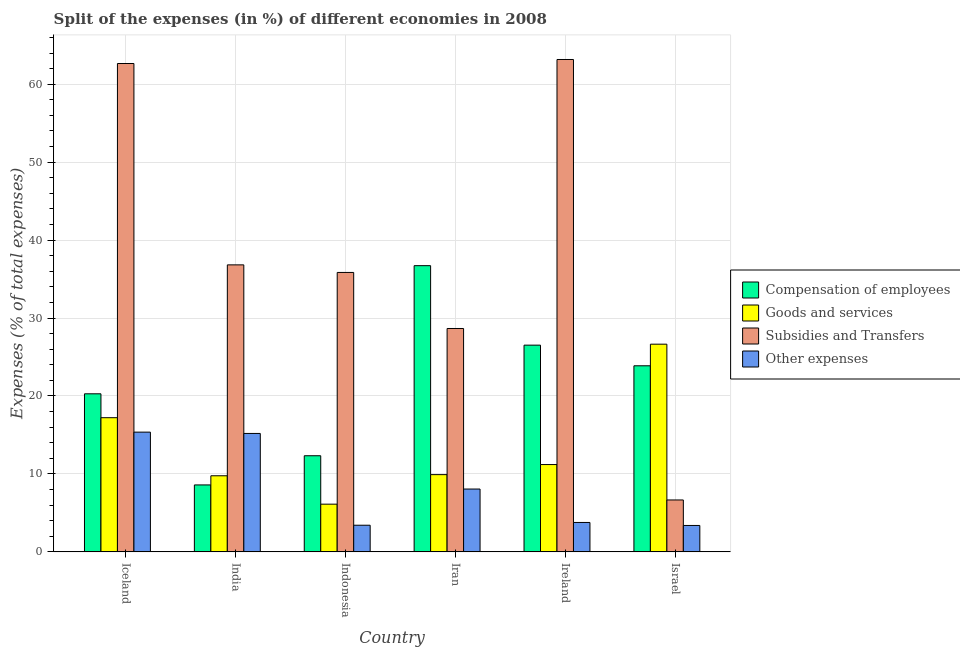How many different coloured bars are there?
Your answer should be very brief. 4. How many groups of bars are there?
Ensure brevity in your answer.  6. Are the number of bars per tick equal to the number of legend labels?
Keep it short and to the point. Yes. Are the number of bars on each tick of the X-axis equal?
Keep it short and to the point. Yes. How many bars are there on the 1st tick from the left?
Provide a short and direct response. 4. How many bars are there on the 4th tick from the right?
Ensure brevity in your answer.  4. What is the label of the 5th group of bars from the left?
Make the answer very short. Ireland. What is the percentage of amount spent on subsidies in Indonesia?
Your answer should be very brief. 35.85. Across all countries, what is the maximum percentage of amount spent on compensation of employees?
Your response must be concise. 36.72. Across all countries, what is the minimum percentage of amount spent on goods and services?
Make the answer very short. 6.12. In which country was the percentage of amount spent on subsidies maximum?
Your response must be concise. Ireland. What is the total percentage of amount spent on subsidies in the graph?
Provide a short and direct response. 233.81. What is the difference between the percentage of amount spent on subsidies in Iceland and that in Ireland?
Your response must be concise. -0.52. What is the difference between the percentage of amount spent on compensation of employees in Iceland and the percentage of amount spent on goods and services in Ireland?
Your answer should be very brief. 9.08. What is the average percentage of amount spent on other expenses per country?
Your answer should be very brief. 8.2. What is the difference between the percentage of amount spent on compensation of employees and percentage of amount spent on other expenses in Ireland?
Make the answer very short. 22.75. What is the ratio of the percentage of amount spent on subsidies in Iceland to that in Ireland?
Your response must be concise. 0.99. Is the percentage of amount spent on goods and services in Indonesia less than that in Israel?
Provide a short and direct response. Yes. What is the difference between the highest and the second highest percentage of amount spent on goods and services?
Offer a very short reply. 9.43. What is the difference between the highest and the lowest percentage of amount spent on subsidies?
Give a very brief answer. 56.51. Is the sum of the percentage of amount spent on subsidies in Iceland and Indonesia greater than the maximum percentage of amount spent on other expenses across all countries?
Give a very brief answer. Yes. What does the 2nd bar from the left in Iran represents?
Your response must be concise. Goods and services. What does the 1st bar from the right in Israel represents?
Your answer should be very brief. Other expenses. How many bars are there?
Provide a short and direct response. 24. How are the legend labels stacked?
Your answer should be compact. Vertical. What is the title of the graph?
Provide a succinct answer. Split of the expenses (in %) of different economies in 2008. What is the label or title of the X-axis?
Ensure brevity in your answer.  Country. What is the label or title of the Y-axis?
Ensure brevity in your answer.  Expenses (% of total expenses). What is the Expenses (% of total expenses) of Compensation of employees in Iceland?
Offer a terse response. 20.28. What is the Expenses (% of total expenses) in Goods and services in Iceland?
Keep it short and to the point. 17.22. What is the Expenses (% of total expenses) in Subsidies and Transfers in Iceland?
Your answer should be very brief. 62.65. What is the Expenses (% of total expenses) of Other expenses in Iceland?
Your answer should be compact. 15.36. What is the Expenses (% of total expenses) of Compensation of employees in India?
Provide a succinct answer. 8.59. What is the Expenses (% of total expenses) of Goods and services in India?
Provide a succinct answer. 9.76. What is the Expenses (% of total expenses) in Subsidies and Transfers in India?
Offer a terse response. 36.82. What is the Expenses (% of total expenses) of Other expenses in India?
Provide a succinct answer. 15.19. What is the Expenses (% of total expenses) of Compensation of employees in Indonesia?
Offer a terse response. 12.33. What is the Expenses (% of total expenses) in Goods and services in Indonesia?
Your answer should be very brief. 6.12. What is the Expenses (% of total expenses) in Subsidies and Transfers in Indonesia?
Make the answer very short. 35.85. What is the Expenses (% of total expenses) in Other expenses in Indonesia?
Provide a short and direct response. 3.42. What is the Expenses (% of total expenses) in Compensation of employees in Iran?
Your answer should be compact. 36.72. What is the Expenses (% of total expenses) in Goods and services in Iran?
Make the answer very short. 9.91. What is the Expenses (% of total expenses) in Subsidies and Transfers in Iran?
Your answer should be compact. 28.66. What is the Expenses (% of total expenses) of Other expenses in Iran?
Your answer should be compact. 8.06. What is the Expenses (% of total expenses) of Compensation of employees in Ireland?
Offer a terse response. 26.52. What is the Expenses (% of total expenses) in Goods and services in Ireland?
Keep it short and to the point. 11.2. What is the Expenses (% of total expenses) of Subsidies and Transfers in Ireland?
Keep it short and to the point. 63.17. What is the Expenses (% of total expenses) in Other expenses in Ireland?
Your answer should be compact. 3.77. What is the Expenses (% of total expenses) of Compensation of employees in Israel?
Offer a very short reply. 23.87. What is the Expenses (% of total expenses) of Goods and services in Israel?
Offer a terse response. 26.65. What is the Expenses (% of total expenses) of Subsidies and Transfers in Israel?
Offer a very short reply. 6.66. What is the Expenses (% of total expenses) in Other expenses in Israel?
Your response must be concise. 3.39. Across all countries, what is the maximum Expenses (% of total expenses) in Compensation of employees?
Provide a short and direct response. 36.72. Across all countries, what is the maximum Expenses (% of total expenses) in Goods and services?
Your answer should be compact. 26.65. Across all countries, what is the maximum Expenses (% of total expenses) in Subsidies and Transfers?
Offer a terse response. 63.17. Across all countries, what is the maximum Expenses (% of total expenses) in Other expenses?
Make the answer very short. 15.36. Across all countries, what is the minimum Expenses (% of total expenses) in Compensation of employees?
Your response must be concise. 8.59. Across all countries, what is the minimum Expenses (% of total expenses) of Goods and services?
Your response must be concise. 6.12. Across all countries, what is the minimum Expenses (% of total expenses) of Subsidies and Transfers?
Your answer should be compact. 6.66. Across all countries, what is the minimum Expenses (% of total expenses) in Other expenses?
Keep it short and to the point. 3.39. What is the total Expenses (% of total expenses) of Compensation of employees in the graph?
Make the answer very short. 128.32. What is the total Expenses (% of total expenses) of Goods and services in the graph?
Offer a very short reply. 80.86. What is the total Expenses (% of total expenses) of Subsidies and Transfers in the graph?
Provide a short and direct response. 233.81. What is the total Expenses (% of total expenses) of Other expenses in the graph?
Your answer should be compact. 49.2. What is the difference between the Expenses (% of total expenses) of Compensation of employees in Iceland and that in India?
Ensure brevity in your answer.  11.69. What is the difference between the Expenses (% of total expenses) of Goods and services in Iceland and that in India?
Your answer should be compact. 7.45. What is the difference between the Expenses (% of total expenses) in Subsidies and Transfers in Iceland and that in India?
Offer a very short reply. 25.83. What is the difference between the Expenses (% of total expenses) of Other expenses in Iceland and that in India?
Give a very brief answer. 0.17. What is the difference between the Expenses (% of total expenses) of Compensation of employees in Iceland and that in Indonesia?
Offer a very short reply. 7.95. What is the difference between the Expenses (% of total expenses) of Goods and services in Iceland and that in Indonesia?
Provide a succinct answer. 11.09. What is the difference between the Expenses (% of total expenses) of Subsidies and Transfers in Iceland and that in Indonesia?
Provide a succinct answer. 26.81. What is the difference between the Expenses (% of total expenses) in Other expenses in Iceland and that in Indonesia?
Your answer should be compact. 11.94. What is the difference between the Expenses (% of total expenses) in Compensation of employees in Iceland and that in Iran?
Provide a succinct answer. -16.44. What is the difference between the Expenses (% of total expenses) of Goods and services in Iceland and that in Iran?
Ensure brevity in your answer.  7.31. What is the difference between the Expenses (% of total expenses) of Subsidies and Transfers in Iceland and that in Iran?
Your response must be concise. 34. What is the difference between the Expenses (% of total expenses) of Other expenses in Iceland and that in Iran?
Your answer should be very brief. 7.3. What is the difference between the Expenses (% of total expenses) of Compensation of employees in Iceland and that in Ireland?
Your answer should be compact. -6.24. What is the difference between the Expenses (% of total expenses) in Goods and services in Iceland and that in Ireland?
Ensure brevity in your answer.  6.01. What is the difference between the Expenses (% of total expenses) of Subsidies and Transfers in Iceland and that in Ireland?
Provide a short and direct response. -0.52. What is the difference between the Expenses (% of total expenses) of Other expenses in Iceland and that in Ireland?
Provide a short and direct response. 11.59. What is the difference between the Expenses (% of total expenses) in Compensation of employees in Iceland and that in Israel?
Your response must be concise. -3.6. What is the difference between the Expenses (% of total expenses) of Goods and services in Iceland and that in Israel?
Keep it short and to the point. -9.43. What is the difference between the Expenses (% of total expenses) of Subsidies and Transfers in Iceland and that in Israel?
Keep it short and to the point. 56. What is the difference between the Expenses (% of total expenses) in Other expenses in Iceland and that in Israel?
Your response must be concise. 11.97. What is the difference between the Expenses (% of total expenses) in Compensation of employees in India and that in Indonesia?
Offer a terse response. -3.74. What is the difference between the Expenses (% of total expenses) in Goods and services in India and that in Indonesia?
Your response must be concise. 3.64. What is the difference between the Expenses (% of total expenses) in Subsidies and Transfers in India and that in Indonesia?
Give a very brief answer. 0.97. What is the difference between the Expenses (% of total expenses) in Other expenses in India and that in Indonesia?
Your answer should be compact. 11.77. What is the difference between the Expenses (% of total expenses) in Compensation of employees in India and that in Iran?
Provide a succinct answer. -28.13. What is the difference between the Expenses (% of total expenses) in Goods and services in India and that in Iran?
Offer a terse response. -0.15. What is the difference between the Expenses (% of total expenses) of Subsidies and Transfers in India and that in Iran?
Provide a short and direct response. 8.16. What is the difference between the Expenses (% of total expenses) in Other expenses in India and that in Iran?
Make the answer very short. 7.13. What is the difference between the Expenses (% of total expenses) of Compensation of employees in India and that in Ireland?
Your response must be concise. -17.93. What is the difference between the Expenses (% of total expenses) in Goods and services in India and that in Ireland?
Keep it short and to the point. -1.44. What is the difference between the Expenses (% of total expenses) in Subsidies and Transfers in India and that in Ireland?
Your answer should be very brief. -26.35. What is the difference between the Expenses (% of total expenses) in Other expenses in India and that in Ireland?
Your answer should be compact. 11.42. What is the difference between the Expenses (% of total expenses) in Compensation of employees in India and that in Israel?
Ensure brevity in your answer.  -15.29. What is the difference between the Expenses (% of total expenses) in Goods and services in India and that in Israel?
Make the answer very short. -16.88. What is the difference between the Expenses (% of total expenses) in Subsidies and Transfers in India and that in Israel?
Offer a very short reply. 30.16. What is the difference between the Expenses (% of total expenses) of Other expenses in India and that in Israel?
Provide a succinct answer. 11.8. What is the difference between the Expenses (% of total expenses) of Compensation of employees in Indonesia and that in Iran?
Your answer should be very brief. -24.39. What is the difference between the Expenses (% of total expenses) in Goods and services in Indonesia and that in Iran?
Provide a short and direct response. -3.79. What is the difference between the Expenses (% of total expenses) of Subsidies and Transfers in Indonesia and that in Iran?
Your answer should be very brief. 7.19. What is the difference between the Expenses (% of total expenses) in Other expenses in Indonesia and that in Iran?
Give a very brief answer. -4.64. What is the difference between the Expenses (% of total expenses) in Compensation of employees in Indonesia and that in Ireland?
Provide a short and direct response. -14.19. What is the difference between the Expenses (% of total expenses) in Goods and services in Indonesia and that in Ireland?
Your answer should be very brief. -5.08. What is the difference between the Expenses (% of total expenses) in Subsidies and Transfers in Indonesia and that in Ireland?
Keep it short and to the point. -27.32. What is the difference between the Expenses (% of total expenses) of Other expenses in Indonesia and that in Ireland?
Provide a short and direct response. -0.35. What is the difference between the Expenses (% of total expenses) in Compensation of employees in Indonesia and that in Israel?
Keep it short and to the point. -11.54. What is the difference between the Expenses (% of total expenses) in Goods and services in Indonesia and that in Israel?
Ensure brevity in your answer.  -20.52. What is the difference between the Expenses (% of total expenses) of Subsidies and Transfers in Indonesia and that in Israel?
Provide a short and direct response. 29.19. What is the difference between the Expenses (% of total expenses) in Other expenses in Indonesia and that in Israel?
Give a very brief answer. 0.03. What is the difference between the Expenses (% of total expenses) in Compensation of employees in Iran and that in Ireland?
Ensure brevity in your answer.  10.2. What is the difference between the Expenses (% of total expenses) in Goods and services in Iran and that in Ireland?
Provide a short and direct response. -1.29. What is the difference between the Expenses (% of total expenses) in Subsidies and Transfers in Iran and that in Ireland?
Your answer should be very brief. -34.51. What is the difference between the Expenses (% of total expenses) in Other expenses in Iran and that in Ireland?
Provide a succinct answer. 4.29. What is the difference between the Expenses (% of total expenses) of Compensation of employees in Iran and that in Israel?
Your response must be concise. 12.85. What is the difference between the Expenses (% of total expenses) of Goods and services in Iran and that in Israel?
Provide a short and direct response. -16.74. What is the difference between the Expenses (% of total expenses) in Subsidies and Transfers in Iran and that in Israel?
Keep it short and to the point. 22. What is the difference between the Expenses (% of total expenses) of Other expenses in Iran and that in Israel?
Keep it short and to the point. 4.67. What is the difference between the Expenses (% of total expenses) of Compensation of employees in Ireland and that in Israel?
Your answer should be very brief. 2.65. What is the difference between the Expenses (% of total expenses) of Goods and services in Ireland and that in Israel?
Provide a succinct answer. -15.44. What is the difference between the Expenses (% of total expenses) in Subsidies and Transfers in Ireland and that in Israel?
Your response must be concise. 56.51. What is the difference between the Expenses (% of total expenses) of Other expenses in Ireland and that in Israel?
Your response must be concise. 0.39. What is the difference between the Expenses (% of total expenses) of Compensation of employees in Iceland and the Expenses (% of total expenses) of Goods and services in India?
Keep it short and to the point. 10.52. What is the difference between the Expenses (% of total expenses) of Compensation of employees in Iceland and the Expenses (% of total expenses) of Subsidies and Transfers in India?
Give a very brief answer. -16.54. What is the difference between the Expenses (% of total expenses) of Compensation of employees in Iceland and the Expenses (% of total expenses) of Other expenses in India?
Offer a terse response. 5.08. What is the difference between the Expenses (% of total expenses) of Goods and services in Iceland and the Expenses (% of total expenses) of Subsidies and Transfers in India?
Offer a terse response. -19.61. What is the difference between the Expenses (% of total expenses) of Goods and services in Iceland and the Expenses (% of total expenses) of Other expenses in India?
Provide a short and direct response. 2.02. What is the difference between the Expenses (% of total expenses) of Subsidies and Transfers in Iceland and the Expenses (% of total expenses) of Other expenses in India?
Your response must be concise. 47.46. What is the difference between the Expenses (% of total expenses) of Compensation of employees in Iceland and the Expenses (% of total expenses) of Goods and services in Indonesia?
Your answer should be very brief. 14.16. What is the difference between the Expenses (% of total expenses) in Compensation of employees in Iceland and the Expenses (% of total expenses) in Subsidies and Transfers in Indonesia?
Give a very brief answer. -15.57. What is the difference between the Expenses (% of total expenses) in Compensation of employees in Iceland and the Expenses (% of total expenses) in Other expenses in Indonesia?
Make the answer very short. 16.86. What is the difference between the Expenses (% of total expenses) in Goods and services in Iceland and the Expenses (% of total expenses) in Subsidies and Transfers in Indonesia?
Your answer should be compact. -18.63. What is the difference between the Expenses (% of total expenses) in Goods and services in Iceland and the Expenses (% of total expenses) in Other expenses in Indonesia?
Your answer should be very brief. 13.8. What is the difference between the Expenses (% of total expenses) in Subsidies and Transfers in Iceland and the Expenses (% of total expenses) in Other expenses in Indonesia?
Give a very brief answer. 59.24. What is the difference between the Expenses (% of total expenses) of Compensation of employees in Iceland and the Expenses (% of total expenses) of Goods and services in Iran?
Ensure brevity in your answer.  10.37. What is the difference between the Expenses (% of total expenses) in Compensation of employees in Iceland and the Expenses (% of total expenses) in Subsidies and Transfers in Iran?
Offer a very short reply. -8.38. What is the difference between the Expenses (% of total expenses) of Compensation of employees in Iceland and the Expenses (% of total expenses) of Other expenses in Iran?
Provide a succinct answer. 12.22. What is the difference between the Expenses (% of total expenses) in Goods and services in Iceland and the Expenses (% of total expenses) in Subsidies and Transfers in Iran?
Your response must be concise. -11.44. What is the difference between the Expenses (% of total expenses) in Goods and services in Iceland and the Expenses (% of total expenses) in Other expenses in Iran?
Keep it short and to the point. 9.15. What is the difference between the Expenses (% of total expenses) in Subsidies and Transfers in Iceland and the Expenses (% of total expenses) in Other expenses in Iran?
Provide a short and direct response. 54.59. What is the difference between the Expenses (% of total expenses) in Compensation of employees in Iceland and the Expenses (% of total expenses) in Goods and services in Ireland?
Give a very brief answer. 9.08. What is the difference between the Expenses (% of total expenses) of Compensation of employees in Iceland and the Expenses (% of total expenses) of Subsidies and Transfers in Ireland?
Provide a succinct answer. -42.89. What is the difference between the Expenses (% of total expenses) of Compensation of employees in Iceland and the Expenses (% of total expenses) of Other expenses in Ireland?
Make the answer very short. 16.5. What is the difference between the Expenses (% of total expenses) in Goods and services in Iceland and the Expenses (% of total expenses) in Subsidies and Transfers in Ireland?
Your response must be concise. -45.95. What is the difference between the Expenses (% of total expenses) in Goods and services in Iceland and the Expenses (% of total expenses) in Other expenses in Ireland?
Your answer should be very brief. 13.44. What is the difference between the Expenses (% of total expenses) in Subsidies and Transfers in Iceland and the Expenses (% of total expenses) in Other expenses in Ireland?
Offer a very short reply. 58.88. What is the difference between the Expenses (% of total expenses) of Compensation of employees in Iceland and the Expenses (% of total expenses) of Goods and services in Israel?
Provide a short and direct response. -6.37. What is the difference between the Expenses (% of total expenses) in Compensation of employees in Iceland and the Expenses (% of total expenses) in Subsidies and Transfers in Israel?
Make the answer very short. 13.62. What is the difference between the Expenses (% of total expenses) of Compensation of employees in Iceland and the Expenses (% of total expenses) of Other expenses in Israel?
Ensure brevity in your answer.  16.89. What is the difference between the Expenses (% of total expenses) of Goods and services in Iceland and the Expenses (% of total expenses) of Subsidies and Transfers in Israel?
Offer a terse response. 10.56. What is the difference between the Expenses (% of total expenses) in Goods and services in Iceland and the Expenses (% of total expenses) in Other expenses in Israel?
Ensure brevity in your answer.  13.83. What is the difference between the Expenses (% of total expenses) of Subsidies and Transfers in Iceland and the Expenses (% of total expenses) of Other expenses in Israel?
Ensure brevity in your answer.  59.27. What is the difference between the Expenses (% of total expenses) in Compensation of employees in India and the Expenses (% of total expenses) in Goods and services in Indonesia?
Make the answer very short. 2.47. What is the difference between the Expenses (% of total expenses) in Compensation of employees in India and the Expenses (% of total expenses) in Subsidies and Transfers in Indonesia?
Offer a very short reply. -27.26. What is the difference between the Expenses (% of total expenses) in Compensation of employees in India and the Expenses (% of total expenses) in Other expenses in Indonesia?
Provide a succinct answer. 5.17. What is the difference between the Expenses (% of total expenses) of Goods and services in India and the Expenses (% of total expenses) of Subsidies and Transfers in Indonesia?
Make the answer very short. -26.09. What is the difference between the Expenses (% of total expenses) of Goods and services in India and the Expenses (% of total expenses) of Other expenses in Indonesia?
Your answer should be very brief. 6.34. What is the difference between the Expenses (% of total expenses) in Subsidies and Transfers in India and the Expenses (% of total expenses) in Other expenses in Indonesia?
Your answer should be very brief. 33.4. What is the difference between the Expenses (% of total expenses) of Compensation of employees in India and the Expenses (% of total expenses) of Goods and services in Iran?
Your response must be concise. -1.32. What is the difference between the Expenses (% of total expenses) of Compensation of employees in India and the Expenses (% of total expenses) of Subsidies and Transfers in Iran?
Keep it short and to the point. -20.07. What is the difference between the Expenses (% of total expenses) of Compensation of employees in India and the Expenses (% of total expenses) of Other expenses in Iran?
Your response must be concise. 0.53. What is the difference between the Expenses (% of total expenses) in Goods and services in India and the Expenses (% of total expenses) in Subsidies and Transfers in Iran?
Provide a short and direct response. -18.89. What is the difference between the Expenses (% of total expenses) of Goods and services in India and the Expenses (% of total expenses) of Other expenses in Iran?
Provide a succinct answer. 1.7. What is the difference between the Expenses (% of total expenses) in Subsidies and Transfers in India and the Expenses (% of total expenses) in Other expenses in Iran?
Keep it short and to the point. 28.76. What is the difference between the Expenses (% of total expenses) in Compensation of employees in India and the Expenses (% of total expenses) in Goods and services in Ireland?
Your answer should be compact. -2.61. What is the difference between the Expenses (% of total expenses) in Compensation of employees in India and the Expenses (% of total expenses) in Subsidies and Transfers in Ireland?
Your answer should be very brief. -54.58. What is the difference between the Expenses (% of total expenses) in Compensation of employees in India and the Expenses (% of total expenses) in Other expenses in Ireland?
Ensure brevity in your answer.  4.81. What is the difference between the Expenses (% of total expenses) in Goods and services in India and the Expenses (% of total expenses) in Subsidies and Transfers in Ireland?
Your answer should be very brief. -53.41. What is the difference between the Expenses (% of total expenses) of Goods and services in India and the Expenses (% of total expenses) of Other expenses in Ireland?
Offer a very short reply. 5.99. What is the difference between the Expenses (% of total expenses) in Subsidies and Transfers in India and the Expenses (% of total expenses) in Other expenses in Ireland?
Keep it short and to the point. 33.05. What is the difference between the Expenses (% of total expenses) of Compensation of employees in India and the Expenses (% of total expenses) of Goods and services in Israel?
Your response must be concise. -18.06. What is the difference between the Expenses (% of total expenses) in Compensation of employees in India and the Expenses (% of total expenses) in Subsidies and Transfers in Israel?
Provide a short and direct response. 1.93. What is the difference between the Expenses (% of total expenses) in Compensation of employees in India and the Expenses (% of total expenses) in Other expenses in Israel?
Give a very brief answer. 5.2. What is the difference between the Expenses (% of total expenses) of Goods and services in India and the Expenses (% of total expenses) of Subsidies and Transfers in Israel?
Offer a terse response. 3.1. What is the difference between the Expenses (% of total expenses) in Goods and services in India and the Expenses (% of total expenses) in Other expenses in Israel?
Offer a terse response. 6.37. What is the difference between the Expenses (% of total expenses) of Subsidies and Transfers in India and the Expenses (% of total expenses) of Other expenses in Israel?
Provide a succinct answer. 33.43. What is the difference between the Expenses (% of total expenses) of Compensation of employees in Indonesia and the Expenses (% of total expenses) of Goods and services in Iran?
Keep it short and to the point. 2.42. What is the difference between the Expenses (% of total expenses) in Compensation of employees in Indonesia and the Expenses (% of total expenses) in Subsidies and Transfers in Iran?
Your response must be concise. -16.33. What is the difference between the Expenses (% of total expenses) of Compensation of employees in Indonesia and the Expenses (% of total expenses) of Other expenses in Iran?
Make the answer very short. 4.27. What is the difference between the Expenses (% of total expenses) of Goods and services in Indonesia and the Expenses (% of total expenses) of Subsidies and Transfers in Iran?
Your response must be concise. -22.54. What is the difference between the Expenses (% of total expenses) of Goods and services in Indonesia and the Expenses (% of total expenses) of Other expenses in Iran?
Keep it short and to the point. -1.94. What is the difference between the Expenses (% of total expenses) in Subsidies and Transfers in Indonesia and the Expenses (% of total expenses) in Other expenses in Iran?
Make the answer very short. 27.79. What is the difference between the Expenses (% of total expenses) in Compensation of employees in Indonesia and the Expenses (% of total expenses) in Goods and services in Ireland?
Keep it short and to the point. 1.13. What is the difference between the Expenses (% of total expenses) in Compensation of employees in Indonesia and the Expenses (% of total expenses) in Subsidies and Transfers in Ireland?
Give a very brief answer. -50.84. What is the difference between the Expenses (% of total expenses) of Compensation of employees in Indonesia and the Expenses (% of total expenses) of Other expenses in Ireland?
Your answer should be compact. 8.56. What is the difference between the Expenses (% of total expenses) of Goods and services in Indonesia and the Expenses (% of total expenses) of Subsidies and Transfers in Ireland?
Give a very brief answer. -57.05. What is the difference between the Expenses (% of total expenses) of Goods and services in Indonesia and the Expenses (% of total expenses) of Other expenses in Ireland?
Offer a very short reply. 2.35. What is the difference between the Expenses (% of total expenses) of Subsidies and Transfers in Indonesia and the Expenses (% of total expenses) of Other expenses in Ireland?
Offer a terse response. 32.07. What is the difference between the Expenses (% of total expenses) of Compensation of employees in Indonesia and the Expenses (% of total expenses) of Goods and services in Israel?
Offer a very short reply. -14.31. What is the difference between the Expenses (% of total expenses) of Compensation of employees in Indonesia and the Expenses (% of total expenses) of Subsidies and Transfers in Israel?
Ensure brevity in your answer.  5.67. What is the difference between the Expenses (% of total expenses) of Compensation of employees in Indonesia and the Expenses (% of total expenses) of Other expenses in Israel?
Ensure brevity in your answer.  8.94. What is the difference between the Expenses (% of total expenses) of Goods and services in Indonesia and the Expenses (% of total expenses) of Subsidies and Transfers in Israel?
Offer a very short reply. -0.54. What is the difference between the Expenses (% of total expenses) in Goods and services in Indonesia and the Expenses (% of total expenses) in Other expenses in Israel?
Your response must be concise. 2.73. What is the difference between the Expenses (% of total expenses) of Subsidies and Transfers in Indonesia and the Expenses (% of total expenses) of Other expenses in Israel?
Give a very brief answer. 32.46. What is the difference between the Expenses (% of total expenses) in Compensation of employees in Iran and the Expenses (% of total expenses) in Goods and services in Ireland?
Your response must be concise. 25.52. What is the difference between the Expenses (% of total expenses) in Compensation of employees in Iran and the Expenses (% of total expenses) in Subsidies and Transfers in Ireland?
Your answer should be compact. -26.45. What is the difference between the Expenses (% of total expenses) in Compensation of employees in Iran and the Expenses (% of total expenses) in Other expenses in Ireland?
Give a very brief answer. 32.95. What is the difference between the Expenses (% of total expenses) in Goods and services in Iran and the Expenses (% of total expenses) in Subsidies and Transfers in Ireland?
Offer a terse response. -53.26. What is the difference between the Expenses (% of total expenses) of Goods and services in Iran and the Expenses (% of total expenses) of Other expenses in Ireland?
Offer a very short reply. 6.14. What is the difference between the Expenses (% of total expenses) of Subsidies and Transfers in Iran and the Expenses (% of total expenses) of Other expenses in Ireland?
Provide a succinct answer. 24.88. What is the difference between the Expenses (% of total expenses) of Compensation of employees in Iran and the Expenses (% of total expenses) of Goods and services in Israel?
Your answer should be very brief. 10.07. What is the difference between the Expenses (% of total expenses) in Compensation of employees in Iran and the Expenses (% of total expenses) in Subsidies and Transfers in Israel?
Offer a very short reply. 30.06. What is the difference between the Expenses (% of total expenses) in Compensation of employees in Iran and the Expenses (% of total expenses) in Other expenses in Israel?
Offer a terse response. 33.33. What is the difference between the Expenses (% of total expenses) in Goods and services in Iran and the Expenses (% of total expenses) in Subsidies and Transfers in Israel?
Keep it short and to the point. 3.25. What is the difference between the Expenses (% of total expenses) of Goods and services in Iran and the Expenses (% of total expenses) of Other expenses in Israel?
Provide a succinct answer. 6.52. What is the difference between the Expenses (% of total expenses) in Subsidies and Transfers in Iran and the Expenses (% of total expenses) in Other expenses in Israel?
Your answer should be compact. 25.27. What is the difference between the Expenses (% of total expenses) of Compensation of employees in Ireland and the Expenses (% of total expenses) of Goods and services in Israel?
Ensure brevity in your answer.  -0.12. What is the difference between the Expenses (% of total expenses) in Compensation of employees in Ireland and the Expenses (% of total expenses) in Subsidies and Transfers in Israel?
Ensure brevity in your answer.  19.86. What is the difference between the Expenses (% of total expenses) of Compensation of employees in Ireland and the Expenses (% of total expenses) of Other expenses in Israel?
Make the answer very short. 23.13. What is the difference between the Expenses (% of total expenses) of Goods and services in Ireland and the Expenses (% of total expenses) of Subsidies and Transfers in Israel?
Ensure brevity in your answer.  4.54. What is the difference between the Expenses (% of total expenses) of Goods and services in Ireland and the Expenses (% of total expenses) of Other expenses in Israel?
Offer a very short reply. 7.81. What is the difference between the Expenses (% of total expenses) in Subsidies and Transfers in Ireland and the Expenses (% of total expenses) in Other expenses in Israel?
Give a very brief answer. 59.78. What is the average Expenses (% of total expenses) of Compensation of employees per country?
Your response must be concise. 21.39. What is the average Expenses (% of total expenses) of Goods and services per country?
Provide a short and direct response. 13.48. What is the average Expenses (% of total expenses) in Subsidies and Transfers per country?
Make the answer very short. 38.97. What is the average Expenses (% of total expenses) in Other expenses per country?
Your response must be concise. 8.2. What is the difference between the Expenses (% of total expenses) in Compensation of employees and Expenses (% of total expenses) in Goods and services in Iceland?
Ensure brevity in your answer.  3.06. What is the difference between the Expenses (% of total expenses) in Compensation of employees and Expenses (% of total expenses) in Subsidies and Transfers in Iceland?
Ensure brevity in your answer.  -42.38. What is the difference between the Expenses (% of total expenses) in Compensation of employees and Expenses (% of total expenses) in Other expenses in Iceland?
Make the answer very short. 4.92. What is the difference between the Expenses (% of total expenses) of Goods and services and Expenses (% of total expenses) of Subsidies and Transfers in Iceland?
Your response must be concise. -45.44. What is the difference between the Expenses (% of total expenses) in Goods and services and Expenses (% of total expenses) in Other expenses in Iceland?
Keep it short and to the point. 1.85. What is the difference between the Expenses (% of total expenses) in Subsidies and Transfers and Expenses (% of total expenses) in Other expenses in Iceland?
Your answer should be compact. 47.29. What is the difference between the Expenses (% of total expenses) in Compensation of employees and Expenses (% of total expenses) in Goods and services in India?
Make the answer very short. -1.17. What is the difference between the Expenses (% of total expenses) in Compensation of employees and Expenses (% of total expenses) in Subsidies and Transfers in India?
Provide a short and direct response. -28.23. What is the difference between the Expenses (% of total expenses) in Compensation of employees and Expenses (% of total expenses) in Other expenses in India?
Keep it short and to the point. -6.61. What is the difference between the Expenses (% of total expenses) of Goods and services and Expenses (% of total expenses) of Subsidies and Transfers in India?
Your response must be concise. -27.06. What is the difference between the Expenses (% of total expenses) of Goods and services and Expenses (% of total expenses) of Other expenses in India?
Your response must be concise. -5.43. What is the difference between the Expenses (% of total expenses) in Subsidies and Transfers and Expenses (% of total expenses) in Other expenses in India?
Your answer should be very brief. 21.63. What is the difference between the Expenses (% of total expenses) in Compensation of employees and Expenses (% of total expenses) in Goods and services in Indonesia?
Ensure brevity in your answer.  6.21. What is the difference between the Expenses (% of total expenses) of Compensation of employees and Expenses (% of total expenses) of Subsidies and Transfers in Indonesia?
Make the answer very short. -23.52. What is the difference between the Expenses (% of total expenses) of Compensation of employees and Expenses (% of total expenses) of Other expenses in Indonesia?
Your response must be concise. 8.91. What is the difference between the Expenses (% of total expenses) of Goods and services and Expenses (% of total expenses) of Subsidies and Transfers in Indonesia?
Provide a succinct answer. -29.73. What is the difference between the Expenses (% of total expenses) of Goods and services and Expenses (% of total expenses) of Other expenses in Indonesia?
Your response must be concise. 2.7. What is the difference between the Expenses (% of total expenses) of Subsidies and Transfers and Expenses (% of total expenses) of Other expenses in Indonesia?
Offer a terse response. 32.43. What is the difference between the Expenses (% of total expenses) of Compensation of employees and Expenses (% of total expenses) of Goods and services in Iran?
Offer a very short reply. 26.81. What is the difference between the Expenses (% of total expenses) in Compensation of employees and Expenses (% of total expenses) in Subsidies and Transfers in Iran?
Your answer should be compact. 8.06. What is the difference between the Expenses (% of total expenses) in Compensation of employees and Expenses (% of total expenses) in Other expenses in Iran?
Offer a very short reply. 28.66. What is the difference between the Expenses (% of total expenses) of Goods and services and Expenses (% of total expenses) of Subsidies and Transfers in Iran?
Keep it short and to the point. -18.75. What is the difference between the Expenses (% of total expenses) of Goods and services and Expenses (% of total expenses) of Other expenses in Iran?
Provide a succinct answer. 1.85. What is the difference between the Expenses (% of total expenses) of Subsidies and Transfers and Expenses (% of total expenses) of Other expenses in Iran?
Make the answer very short. 20.6. What is the difference between the Expenses (% of total expenses) of Compensation of employees and Expenses (% of total expenses) of Goods and services in Ireland?
Make the answer very short. 15.32. What is the difference between the Expenses (% of total expenses) in Compensation of employees and Expenses (% of total expenses) in Subsidies and Transfers in Ireland?
Make the answer very short. -36.65. What is the difference between the Expenses (% of total expenses) in Compensation of employees and Expenses (% of total expenses) in Other expenses in Ireland?
Give a very brief answer. 22.75. What is the difference between the Expenses (% of total expenses) in Goods and services and Expenses (% of total expenses) in Subsidies and Transfers in Ireland?
Your answer should be compact. -51.97. What is the difference between the Expenses (% of total expenses) of Goods and services and Expenses (% of total expenses) of Other expenses in Ireland?
Offer a very short reply. 7.43. What is the difference between the Expenses (% of total expenses) of Subsidies and Transfers and Expenses (% of total expenses) of Other expenses in Ireland?
Give a very brief answer. 59.4. What is the difference between the Expenses (% of total expenses) in Compensation of employees and Expenses (% of total expenses) in Goods and services in Israel?
Offer a very short reply. -2.77. What is the difference between the Expenses (% of total expenses) of Compensation of employees and Expenses (% of total expenses) of Subsidies and Transfers in Israel?
Provide a short and direct response. 17.22. What is the difference between the Expenses (% of total expenses) in Compensation of employees and Expenses (% of total expenses) in Other expenses in Israel?
Give a very brief answer. 20.49. What is the difference between the Expenses (% of total expenses) of Goods and services and Expenses (% of total expenses) of Subsidies and Transfers in Israel?
Provide a succinct answer. 19.99. What is the difference between the Expenses (% of total expenses) in Goods and services and Expenses (% of total expenses) in Other expenses in Israel?
Offer a very short reply. 23.26. What is the difference between the Expenses (% of total expenses) of Subsidies and Transfers and Expenses (% of total expenses) of Other expenses in Israel?
Your answer should be compact. 3.27. What is the ratio of the Expenses (% of total expenses) of Compensation of employees in Iceland to that in India?
Offer a terse response. 2.36. What is the ratio of the Expenses (% of total expenses) in Goods and services in Iceland to that in India?
Your response must be concise. 1.76. What is the ratio of the Expenses (% of total expenses) of Subsidies and Transfers in Iceland to that in India?
Provide a succinct answer. 1.7. What is the ratio of the Expenses (% of total expenses) of Other expenses in Iceland to that in India?
Give a very brief answer. 1.01. What is the ratio of the Expenses (% of total expenses) of Compensation of employees in Iceland to that in Indonesia?
Your answer should be compact. 1.64. What is the ratio of the Expenses (% of total expenses) of Goods and services in Iceland to that in Indonesia?
Provide a short and direct response. 2.81. What is the ratio of the Expenses (% of total expenses) in Subsidies and Transfers in Iceland to that in Indonesia?
Your answer should be very brief. 1.75. What is the ratio of the Expenses (% of total expenses) of Other expenses in Iceland to that in Indonesia?
Make the answer very short. 4.49. What is the ratio of the Expenses (% of total expenses) in Compensation of employees in Iceland to that in Iran?
Your answer should be very brief. 0.55. What is the ratio of the Expenses (% of total expenses) of Goods and services in Iceland to that in Iran?
Offer a terse response. 1.74. What is the ratio of the Expenses (% of total expenses) in Subsidies and Transfers in Iceland to that in Iran?
Your response must be concise. 2.19. What is the ratio of the Expenses (% of total expenses) in Other expenses in Iceland to that in Iran?
Ensure brevity in your answer.  1.91. What is the ratio of the Expenses (% of total expenses) in Compensation of employees in Iceland to that in Ireland?
Your answer should be compact. 0.76. What is the ratio of the Expenses (% of total expenses) of Goods and services in Iceland to that in Ireland?
Ensure brevity in your answer.  1.54. What is the ratio of the Expenses (% of total expenses) in Other expenses in Iceland to that in Ireland?
Provide a succinct answer. 4.07. What is the ratio of the Expenses (% of total expenses) in Compensation of employees in Iceland to that in Israel?
Your response must be concise. 0.85. What is the ratio of the Expenses (% of total expenses) in Goods and services in Iceland to that in Israel?
Ensure brevity in your answer.  0.65. What is the ratio of the Expenses (% of total expenses) in Subsidies and Transfers in Iceland to that in Israel?
Your answer should be compact. 9.41. What is the ratio of the Expenses (% of total expenses) in Other expenses in Iceland to that in Israel?
Offer a very short reply. 4.53. What is the ratio of the Expenses (% of total expenses) in Compensation of employees in India to that in Indonesia?
Offer a terse response. 0.7. What is the ratio of the Expenses (% of total expenses) in Goods and services in India to that in Indonesia?
Your answer should be compact. 1.59. What is the ratio of the Expenses (% of total expenses) in Subsidies and Transfers in India to that in Indonesia?
Your response must be concise. 1.03. What is the ratio of the Expenses (% of total expenses) in Other expenses in India to that in Indonesia?
Give a very brief answer. 4.44. What is the ratio of the Expenses (% of total expenses) of Compensation of employees in India to that in Iran?
Your answer should be very brief. 0.23. What is the ratio of the Expenses (% of total expenses) in Subsidies and Transfers in India to that in Iran?
Offer a terse response. 1.28. What is the ratio of the Expenses (% of total expenses) of Other expenses in India to that in Iran?
Keep it short and to the point. 1.88. What is the ratio of the Expenses (% of total expenses) of Compensation of employees in India to that in Ireland?
Make the answer very short. 0.32. What is the ratio of the Expenses (% of total expenses) of Goods and services in India to that in Ireland?
Give a very brief answer. 0.87. What is the ratio of the Expenses (% of total expenses) of Subsidies and Transfers in India to that in Ireland?
Make the answer very short. 0.58. What is the ratio of the Expenses (% of total expenses) of Other expenses in India to that in Ireland?
Make the answer very short. 4.03. What is the ratio of the Expenses (% of total expenses) in Compensation of employees in India to that in Israel?
Make the answer very short. 0.36. What is the ratio of the Expenses (% of total expenses) in Goods and services in India to that in Israel?
Keep it short and to the point. 0.37. What is the ratio of the Expenses (% of total expenses) of Subsidies and Transfers in India to that in Israel?
Provide a short and direct response. 5.53. What is the ratio of the Expenses (% of total expenses) of Other expenses in India to that in Israel?
Provide a succinct answer. 4.48. What is the ratio of the Expenses (% of total expenses) in Compensation of employees in Indonesia to that in Iran?
Offer a terse response. 0.34. What is the ratio of the Expenses (% of total expenses) of Goods and services in Indonesia to that in Iran?
Offer a very short reply. 0.62. What is the ratio of the Expenses (% of total expenses) of Subsidies and Transfers in Indonesia to that in Iran?
Offer a terse response. 1.25. What is the ratio of the Expenses (% of total expenses) in Other expenses in Indonesia to that in Iran?
Provide a succinct answer. 0.42. What is the ratio of the Expenses (% of total expenses) in Compensation of employees in Indonesia to that in Ireland?
Offer a very short reply. 0.47. What is the ratio of the Expenses (% of total expenses) of Goods and services in Indonesia to that in Ireland?
Offer a very short reply. 0.55. What is the ratio of the Expenses (% of total expenses) of Subsidies and Transfers in Indonesia to that in Ireland?
Offer a terse response. 0.57. What is the ratio of the Expenses (% of total expenses) in Other expenses in Indonesia to that in Ireland?
Provide a short and direct response. 0.91. What is the ratio of the Expenses (% of total expenses) in Compensation of employees in Indonesia to that in Israel?
Provide a short and direct response. 0.52. What is the ratio of the Expenses (% of total expenses) in Goods and services in Indonesia to that in Israel?
Provide a short and direct response. 0.23. What is the ratio of the Expenses (% of total expenses) in Subsidies and Transfers in Indonesia to that in Israel?
Keep it short and to the point. 5.38. What is the ratio of the Expenses (% of total expenses) of Other expenses in Indonesia to that in Israel?
Provide a succinct answer. 1.01. What is the ratio of the Expenses (% of total expenses) in Compensation of employees in Iran to that in Ireland?
Offer a terse response. 1.38. What is the ratio of the Expenses (% of total expenses) of Goods and services in Iran to that in Ireland?
Your response must be concise. 0.88. What is the ratio of the Expenses (% of total expenses) in Subsidies and Transfers in Iran to that in Ireland?
Give a very brief answer. 0.45. What is the ratio of the Expenses (% of total expenses) in Other expenses in Iran to that in Ireland?
Ensure brevity in your answer.  2.14. What is the ratio of the Expenses (% of total expenses) in Compensation of employees in Iran to that in Israel?
Give a very brief answer. 1.54. What is the ratio of the Expenses (% of total expenses) of Goods and services in Iran to that in Israel?
Your answer should be compact. 0.37. What is the ratio of the Expenses (% of total expenses) of Subsidies and Transfers in Iran to that in Israel?
Ensure brevity in your answer.  4.3. What is the ratio of the Expenses (% of total expenses) in Other expenses in Iran to that in Israel?
Provide a succinct answer. 2.38. What is the ratio of the Expenses (% of total expenses) in Compensation of employees in Ireland to that in Israel?
Offer a very short reply. 1.11. What is the ratio of the Expenses (% of total expenses) of Goods and services in Ireland to that in Israel?
Offer a terse response. 0.42. What is the ratio of the Expenses (% of total expenses) in Subsidies and Transfers in Ireland to that in Israel?
Provide a short and direct response. 9.49. What is the ratio of the Expenses (% of total expenses) in Other expenses in Ireland to that in Israel?
Offer a terse response. 1.11. What is the difference between the highest and the second highest Expenses (% of total expenses) in Compensation of employees?
Keep it short and to the point. 10.2. What is the difference between the highest and the second highest Expenses (% of total expenses) in Goods and services?
Provide a short and direct response. 9.43. What is the difference between the highest and the second highest Expenses (% of total expenses) in Subsidies and Transfers?
Your response must be concise. 0.52. What is the difference between the highest and the second highest Expenses (% of total expenses) of Other expenses?
Give a very brief answer. 0.17. What is the difference between the highest and the lowest Expenses (% of total expenses) of Compensation of employees?
Provide a short and direct response. 28.13. What is the difference between the highest and the lowest Expenses (% of total expenses) of Goods and services?
Your answer should be compact. 20.52. What is the difference between the highest and the lowest Expenses (% of total expenses) in Subsidies and Transfers?
Provide a succinct answer. 56.51. What is the difference between the highest and the lowest Expenses (% of total expenses) of Other expenses?
Provide a short and direct response. 11.97. 